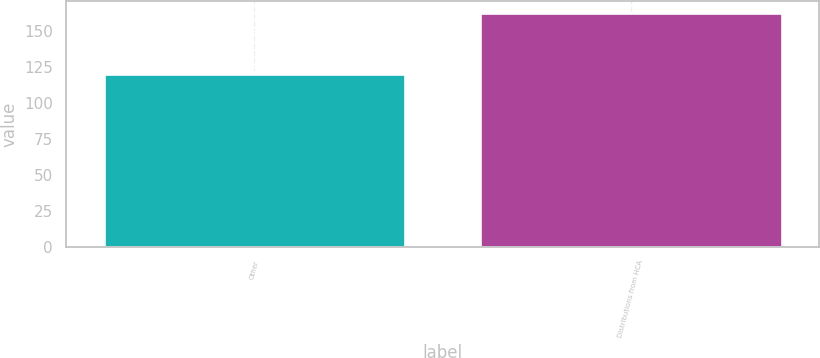Convert chart. <chart><loc_0><loc_0><loc_500><loc_500><bar_chart><fcel>Other<fcel>Distributions from HCA<nl><fcel>120<fcel>163<nl></chart> 